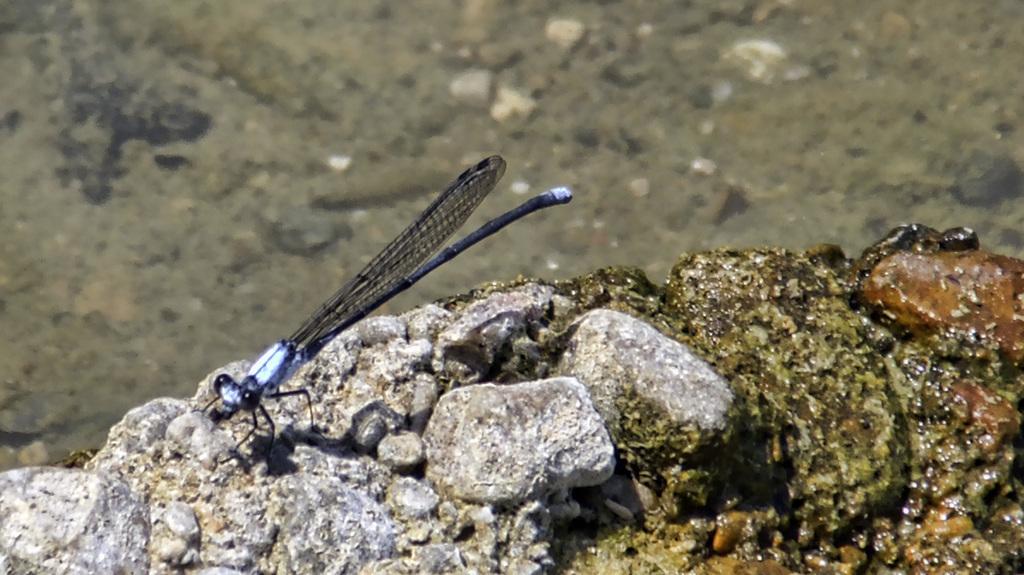Please provide a concise description of this image. This picture contains an insect and at the bottom of the picture, we see stones and rock. In the background, it is green in color and it is blurred. 